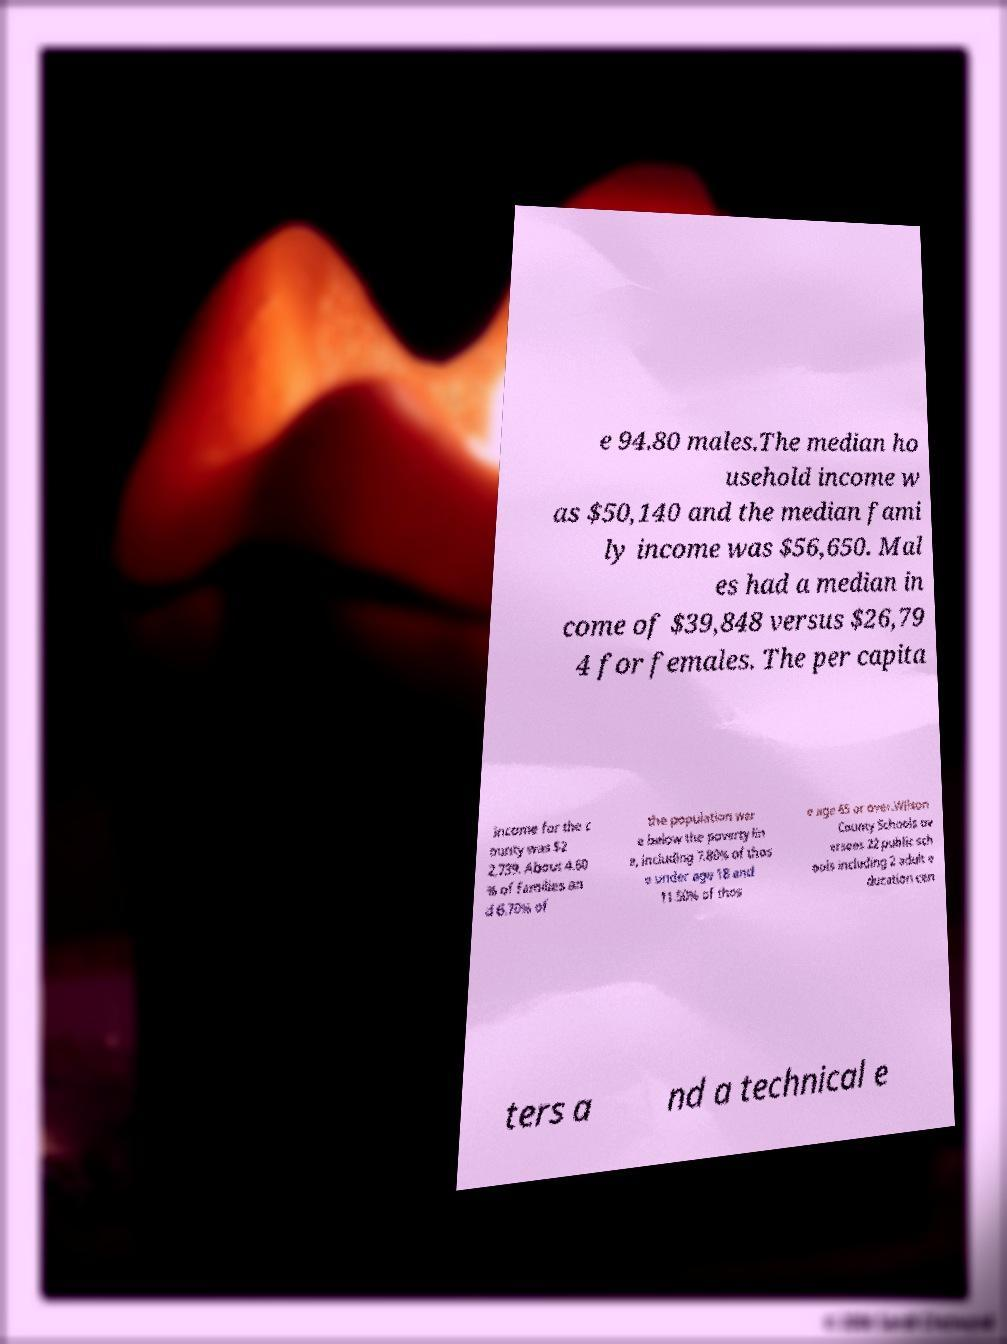There's text embedded in this image that I need extracted. Can you transcribe it verbatim? e 94.80 males.The median ho usehold income w as $50,140 and the median fami ly income was $56,650. Mal es had a median in come of $39,848 versus $26,79 4 for females. The per capita income for the c ounty was $2 2,739. About 4.60 % of families an d 6.70% of the population wer e below the poverty lin e, including 7.80% of thos e under age 18 and 11.50% of thos e age 65 or over.Wilson County Schools ov ersees 22 public sch ools including 2 adult e ducation cen ters a nd a technical e 